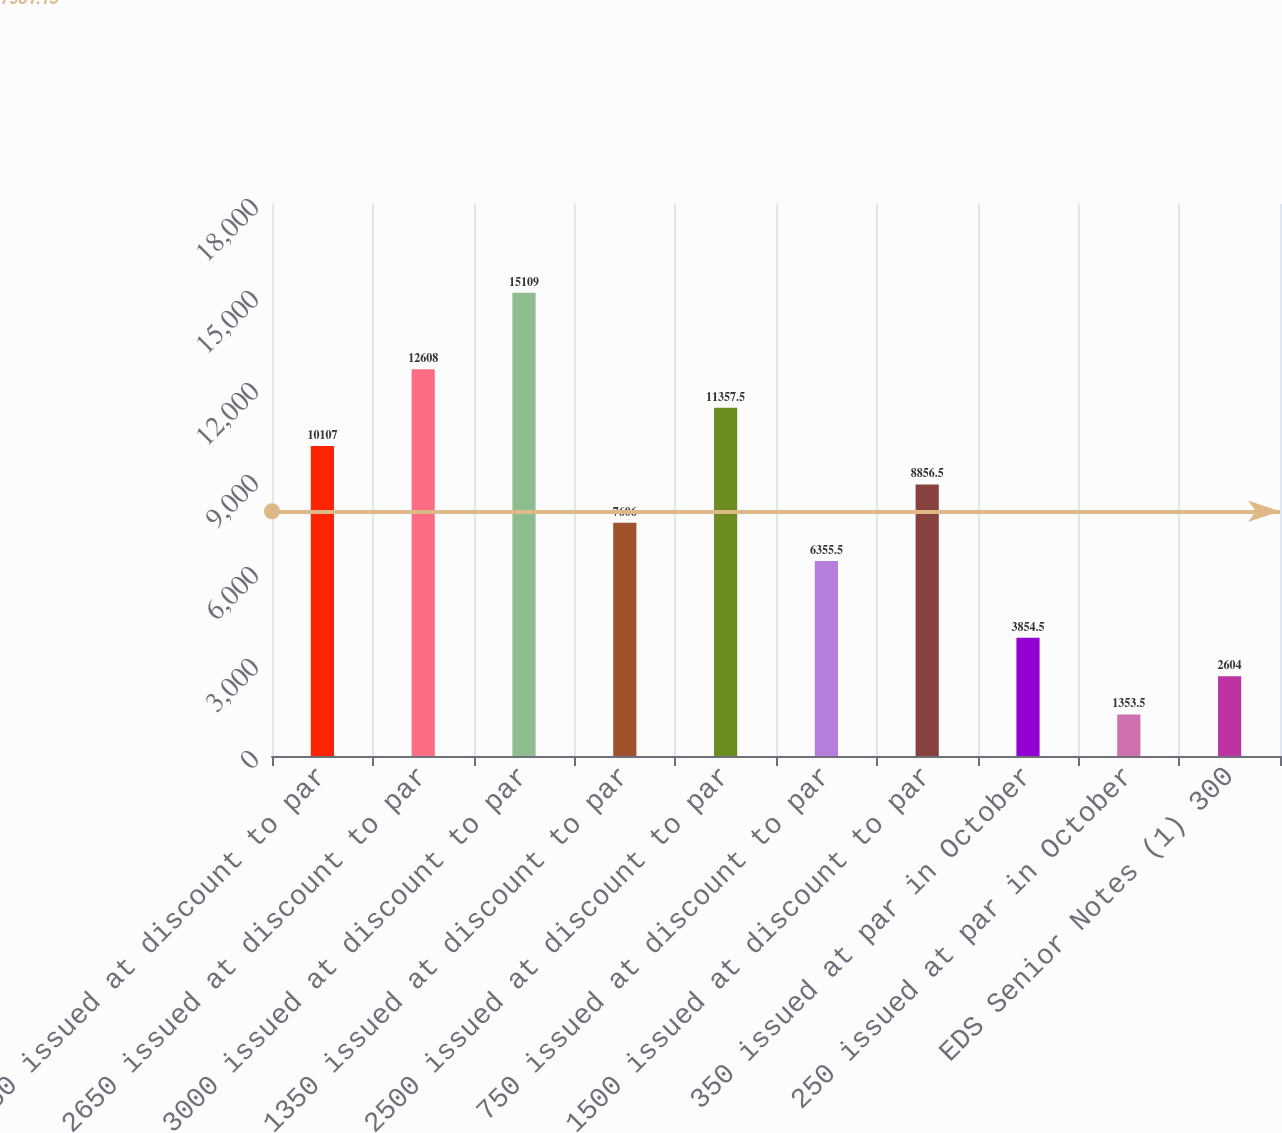Convert chart. <chart><loc_0><loc_0><loc_500><loc_500><bar_chart><fcel>2250 issued at discount to par<fcel>2650 issued at discount to par<fcel>3000 issued at discount to par<fcel>1350 issued at discount to par<fcel>2500 issued at discount to par<fcel>750 issued at discount to par<fcel>1500 issued at discount to par<fcel>350 issued at par in October<fcel>250 issued at par in October<fcel>EDS Senior Notes (1) 300<nl><fcel>10107<fcel>12608<fcel>15109<fcel>7606<fcel>11357.5<fcel>6355.5<fcel>8856.5<fcel>3854.5<fcel>1353.5<fcel>2604<nl></chart> 